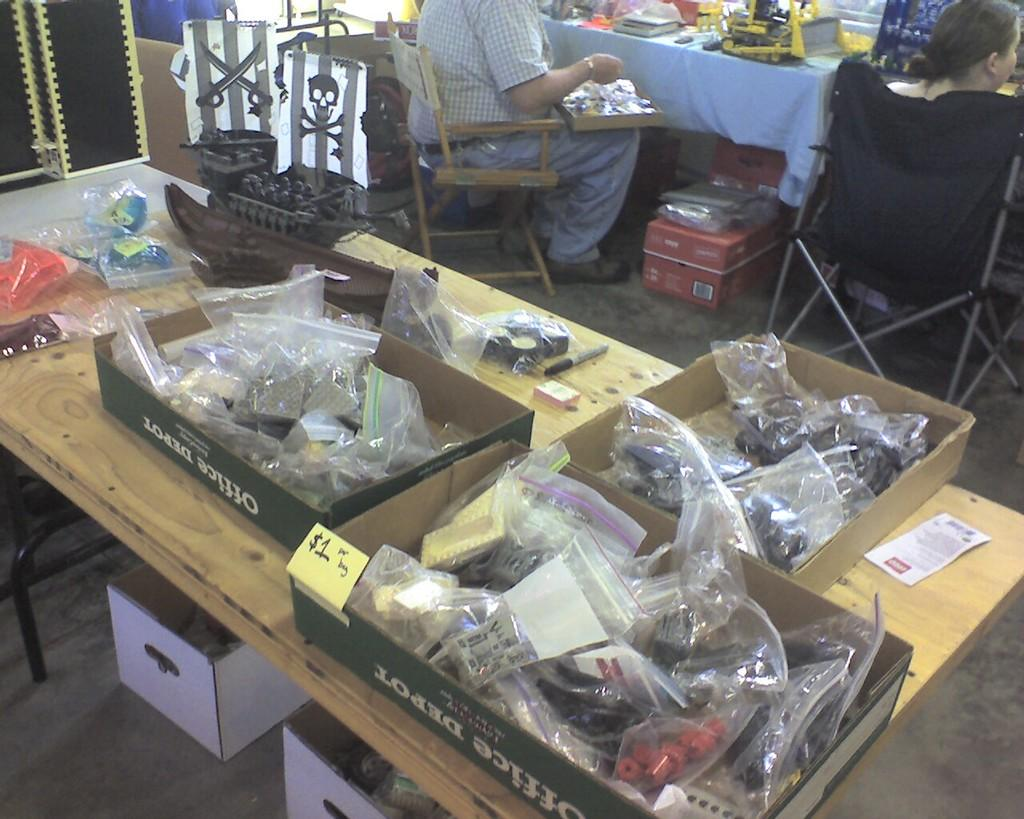What objects are in the foreground of the picture? There are boxes, covers, a table, and toys that look like boats in the foreground of the picture. What type of furniture is present in the foreground of the picture? There is a table in the foreground of the picture. What can be seen at the top of the picture? There are people, chairs, boxes, and various objects at the top of the picture. What invention is being showcased in the picture? There is no specific invention showcased in the picture; it features a variety of objects, including boxes, covers, toys, and furniture. What type of shop is depicted in the picture? There is no shop depicted in the picture; it is a scene with various objects and people. 